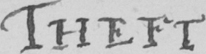Can you read and transcribe this handwriting? Theft 